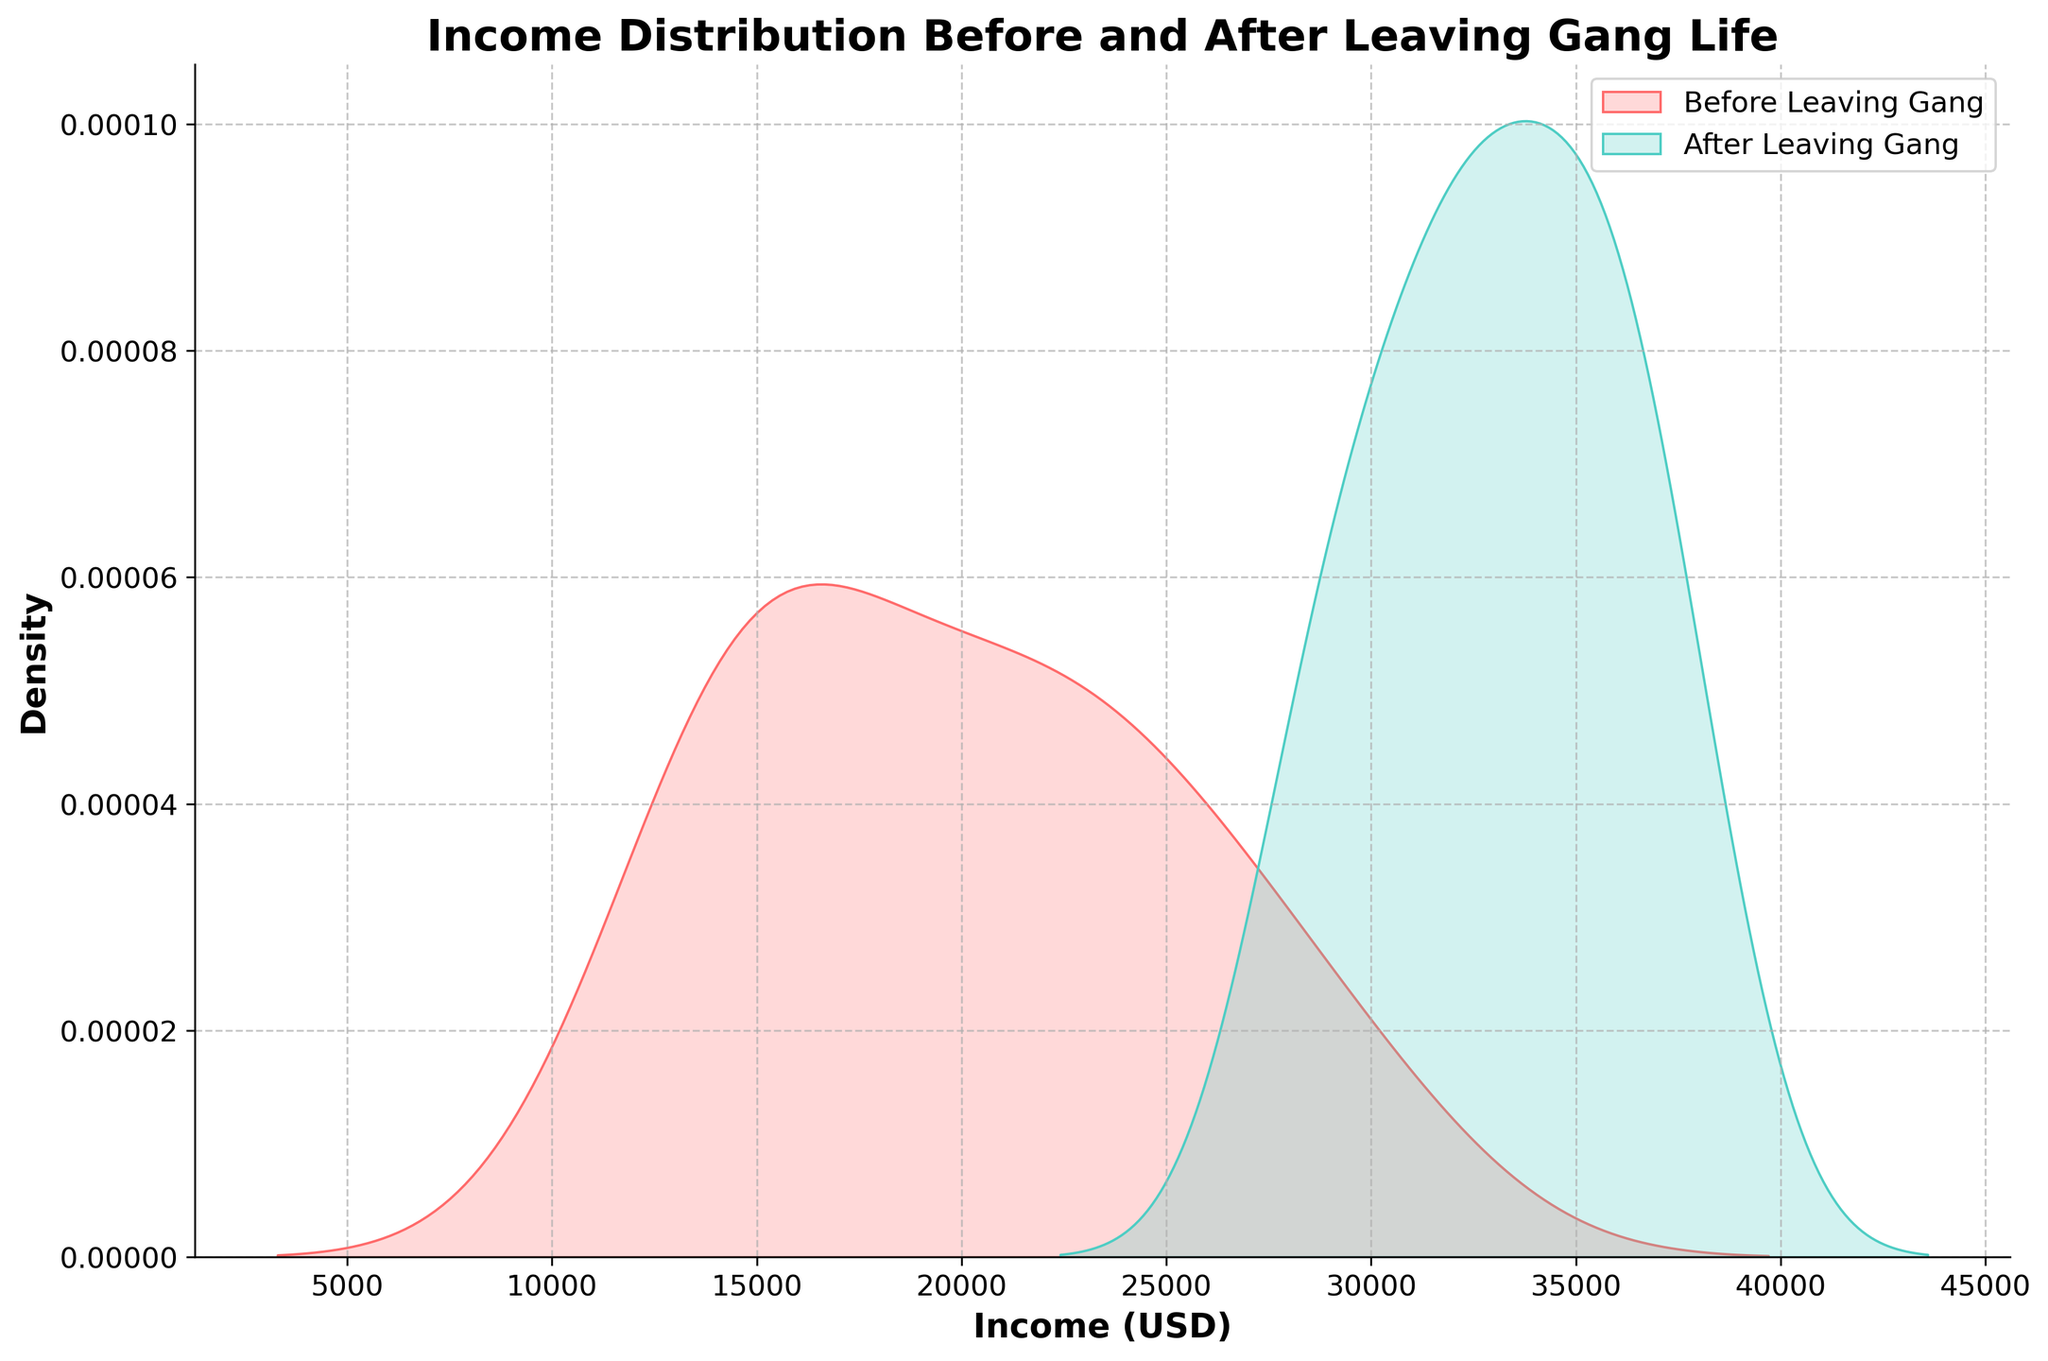what is the title of the figure? The title is usually found at the top of the figure, summarizing what the plot is about. In this case, it is clearly written at the top to describe the content of the figure.
Answer: Income Distribution Before and After Leaving Gang Life What do the x-axis labels represent? The x-axis labels usually indicate the variable being measured. Here, as specified near the bottom of the plot, it represents income amounts in USD.
Answer: Income (USD) What color represents the income distribution before leaving gang life? By looking at the legend, we can see that 'Before Leaving Gang' is labeled with a corresponding color. In this case, it’s identified as a shade of red.
Answer: Red What can be inferred about the trend in income distribution before and after leaving gang life based on the figure? The distributions can be compared visually. It is clear from the overlapped KDE plots that the 'After Leaving Gang' distribution (teal) is shifted to higher income values compared to the 'Before Leaving Gang' distribution (red). This suggests an overall increase in incomes after leaving gang life.
Answer: Income tends to be higher after leaving gang life What is the approximate peak density value for those who left gang life? The peak density value can be identified from the highest point of the 'After Leaving Gang' KDE plot. The plot's highest point appears just above 0.00008.
Answer: ~0.00008 Are there any data points exceeding $35,000 in the 'Before Leaving Gang' income distribution? The KDE plot for 'Before Leaving Gang' does not extend beyond $30,000, indicating that there are no data points in that range of income values.
Answer: No Which group has the larger spread in income distribution? The spread can be visually assessed by observing the width of the KDE plots. The 'After Leaving Gang' KDE plot spreads more widely compared to the 'Before Leaving Gang' plot, suggesting a larger variation in income.
Answer: After Leaving Gang What is the income range with the highest density for individuals before leaving gang life? The highest density in the 'Before Leaving Gang' KDE plot is around the peak, which visually appears to be between $15,000 and $20,000.
Answer: $15,000 - $20,000 What is the income range where both distributions overlap the most? The overlapping region can be identified by examining both KDE curves and finding the common area. It appears that the most overlap occurs around the income range from $27,000 to $30,000.
Answer: $27,000 - $30,000 